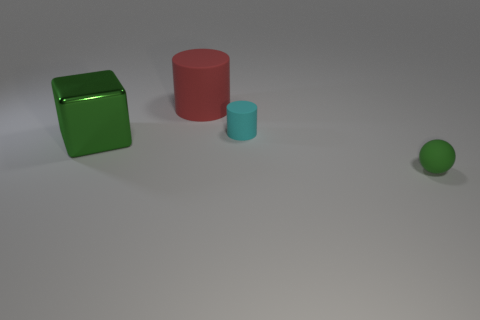Is there any other thing that is the same material as the green block?
Provide a short and direct response. No. What material is the object that is to the right of the large red matte cylinder and behind the big green block?
Offer a very short reply. Rubber. The small rubber object that is behind the small green matte thing is what color?
Make the answer very short. Cyan. Are there more metal cubes in front of the red object than gray matte objects?
Give a very brief answer. Yes. What number of other objects are the same size as the red rubber cylinder?
Your response must be concise. 1. There is a big red matte thing; how many cylinders are in front of it?
Your response must be concise. 1. Is the number of rubber balls that are on the left side of the rubber sphere the same as the number of rubber objects that are in front of the tiny matte cylinder?
Ensure brevity in your answer.  No. There is a red object that is the same shape as the cyan rubber thing; what is its size?
Provide a short and direct response. Large. There is a green object on the left side of the tiny green matte sphere; what is its shape?
Offer a terse response. Cube. Is the material of the green thing left of the red rubber object the same as the small object that is left of the small green matte thing?
Make the answer very short. No. 